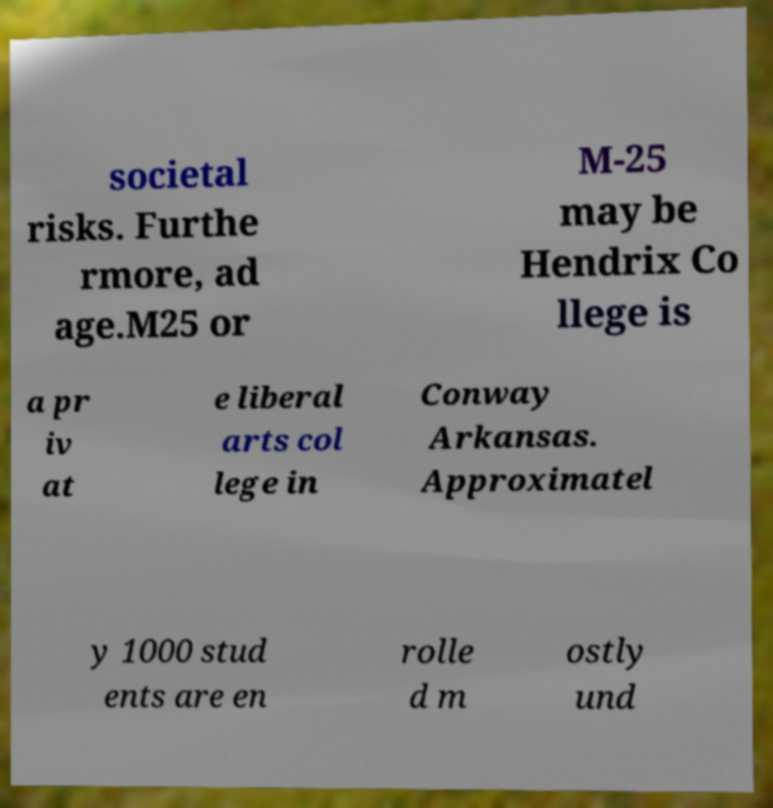For documentation purposes, I need the text within this image transcribed. Could you provide that? societal risks. Furthe rmore, ad age.M25 or M-25 may be Hendrix Co llege is a pr iv at e liberal arts col lege in Conway Arkansas. Approximatel y 1000 stud ents are en rolle d m ostly und 